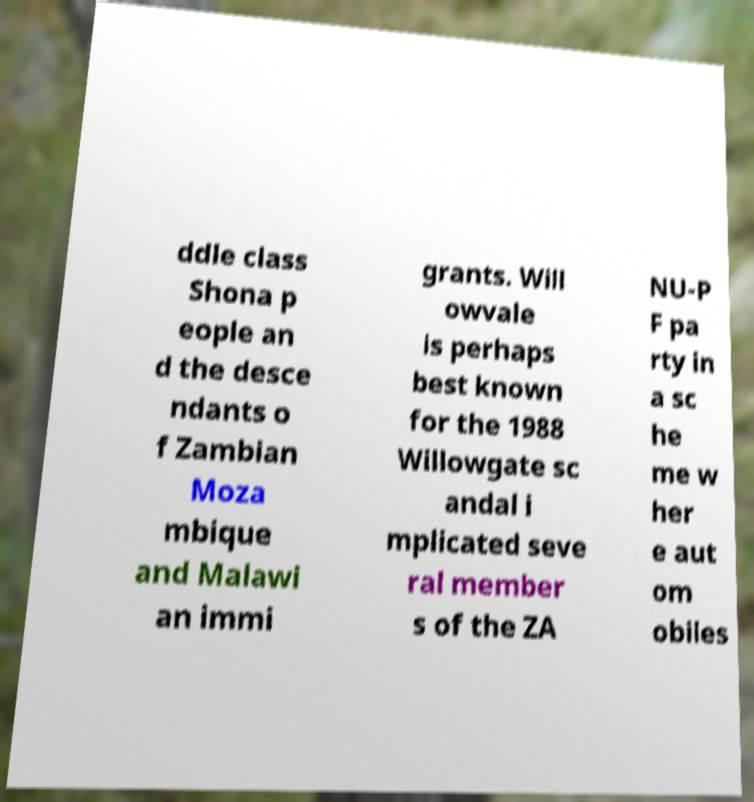What messages or text are displayed in this image? I need them in a readable, typed format. ddle class Shona p eople an d the desce ndants o f Zambian Moza mbique and Malawi an immi grants. Will owvale is perhaps best known for the 1988 Willowgate sc andal i mplicated seve ral member s of the ZA NU-P F pa rty in a sc he me w her e aut om obiles 